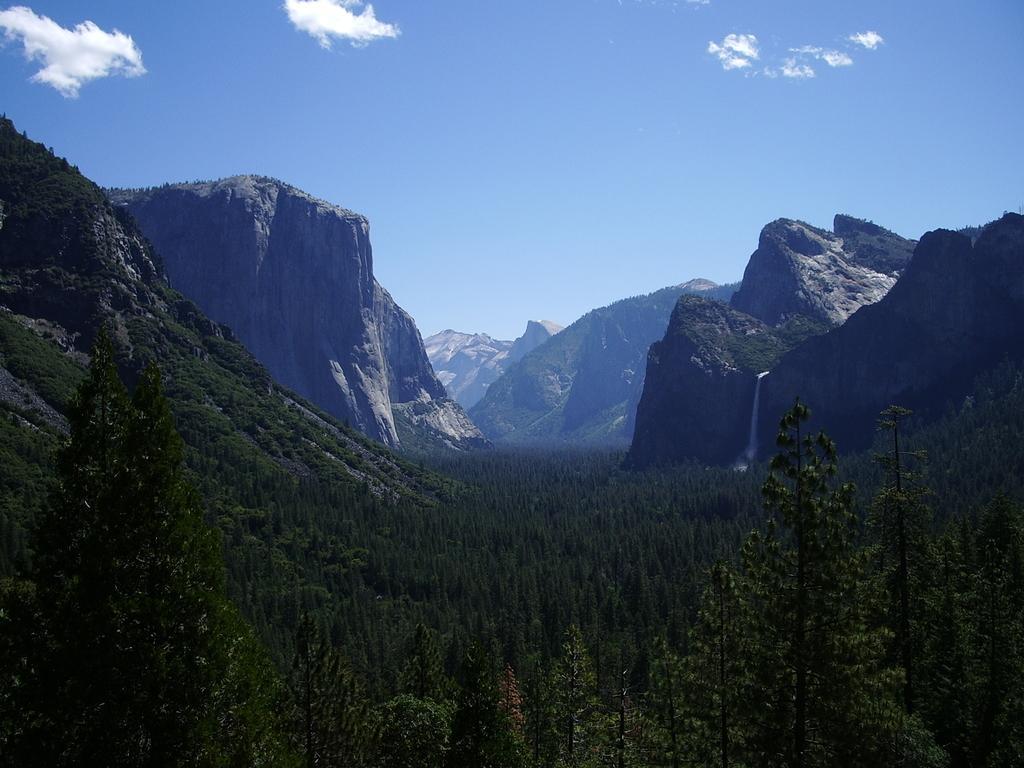Can you describe this image briefly? This picture shows hills and we see trees and a blue cloudy Sky. 